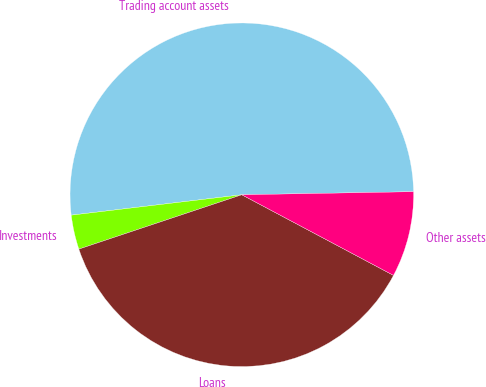Convert chart to OTSL. <chart><loc_0><loc_0><loc_500><loc_500><pie_chart><fcel>Trading account assets<fcel>Investments<fcel>Loans<fcel>Other assets<nl><fcel>51.61%<fcel>3.23%<fcel>37.1%<fcel>8.06%<nl></chart> 